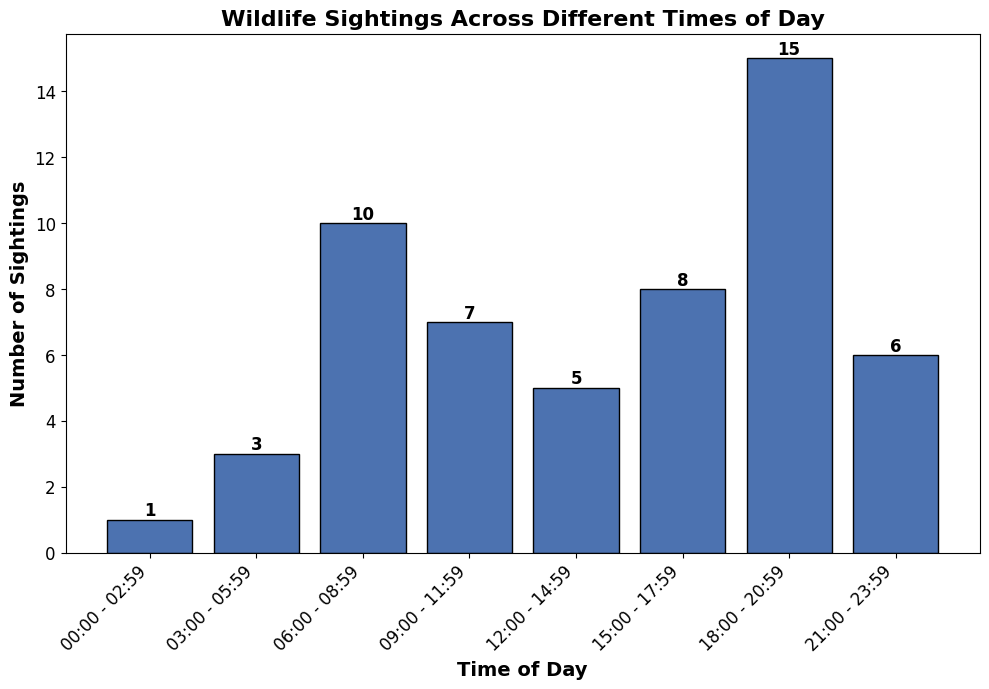What time period has the highest number of wildlife sightings? Look at the bar with the greatest height, which corresponds to the time period with the most wildlife sightings. The highest bar is for 18:00 - 20:59 with 15 sightings.
Answer: 18:00 - 20:59 During which time period were the fewest wildlife sightings recorded? Identify the bar with the shortest height, which indicates the least number of wildlife sightings. The shortest bar corresponds to 00:00 - 02:59 with 1 sighting.
Answer: 00:00 - 02:59 What is the total number of wildlife sightings between 00:00 and 11:59? Sum the values for the relevant bars: 1 (00:00 - 02:59) + 3 (03:00 - 05:59) + 10 (06:00 - 08:59) + 7 (09:00 - 11:59) = 21.
Answer: 21 How many more sightings were recorded at 18:00 - 20:59 than at 06:00 - 08:59? Subtract the number of sightings in the 06:00 - 08:59 period from those in the 18:00 - 20:59 period: 15 - 10 = 5.
Answer: 5 During which time period were sightings more frequent: 09:00 - 11:59 or 15:00 - 17:59? Compare the heights of the bars for each period. The 15:00 - 17:59 period has 8 sightings, while the 09:00 - 11:59 period has 7 sightings. Therefore, sightings are more frequent in the 15:00 - 17:59 period.
Answer: 15:00 - 17:59 What is the average number of wildlife sightings between 00:00 and 08:59? Calculate the average by summing the sightings (1 + 3 + 10) and dividing by the number of intervals (3): (1 + 3 + 10) / 3 = 14 / 3 ≈ 4.67.
Answer: 4.67 Comparing sightings from 00:00 - 05:59 and 21:00 - 23:59, which period has fewer sightings? Add the sightings for 00:00 - 02:59 (1) and 03:00 - 05:59 (3) to get 4, and compare with 21:00 - 23:59 which has 6. Therefore, 00:00 - 05:59 has fewer sightings.
Answer: 00:00 - 05:59 What is the difference in wildlife sightings between the period with the highest and the period with the lowest sightings? Subtract the lowest number of sightings (1 at 00:00 - 02:59) from the highest (15 at 18:00 - 20:59): 15 - 1 = 14.
Answer: 14 What is the total number of wildlife sightings recorded for all time periods combined? Sum the sightings from all bars: 1 + 3 + 10 + 7 + 5 + 8 + 15 + 6 = 55.
Answer: 55 